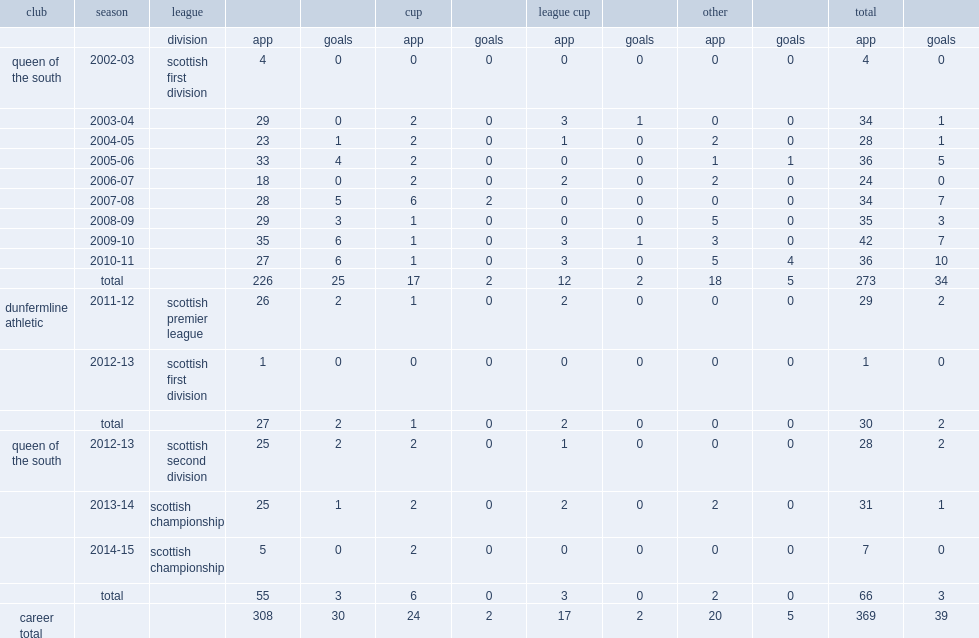How many goals did paul burns score for queen of the south totally? 34.0. 